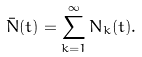<formula> <loc_0><loc_0><loc_500><loc_500>\bar { N } ( t ) = \sum _ { k = 1 } ^ { \infty } N _ { k } ( t ) .</formula> 